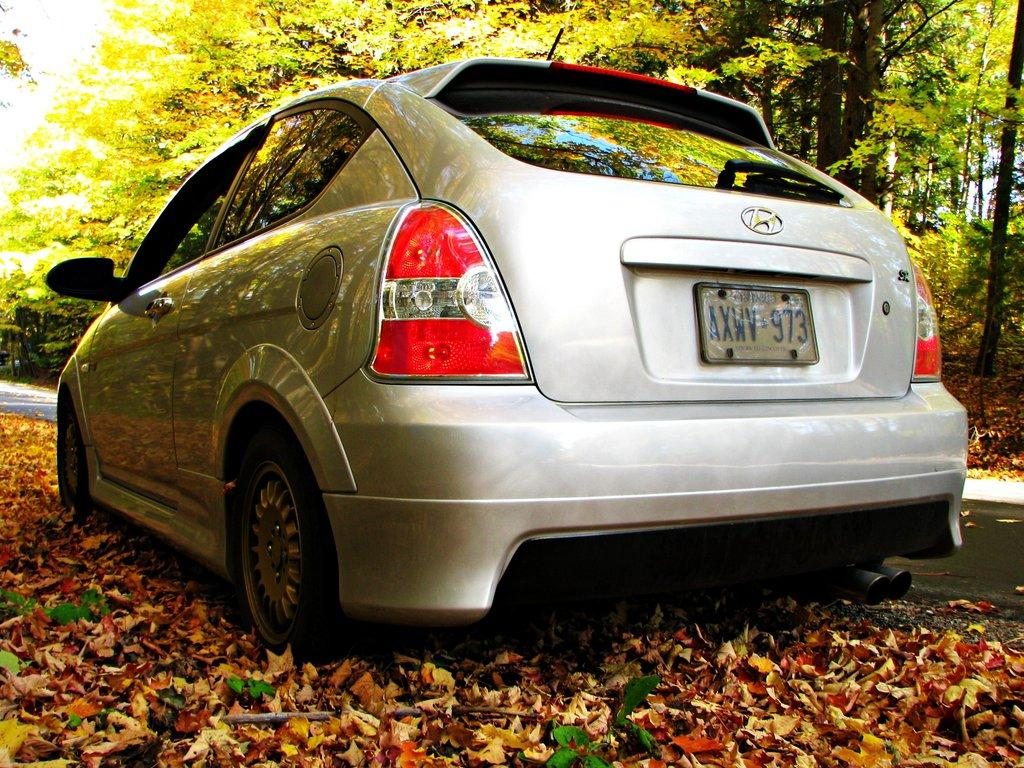What is the main subject in the center of the image? There is a car in the center of the image. What can be seen in the background of the image? There are trees in the background of the image. What is present at the bottom of the image? There are leaves and a walkway at the bottom of the image. What type of cream can be seen dripping from the car in the image? There is no cream dripping from the car in the image. 